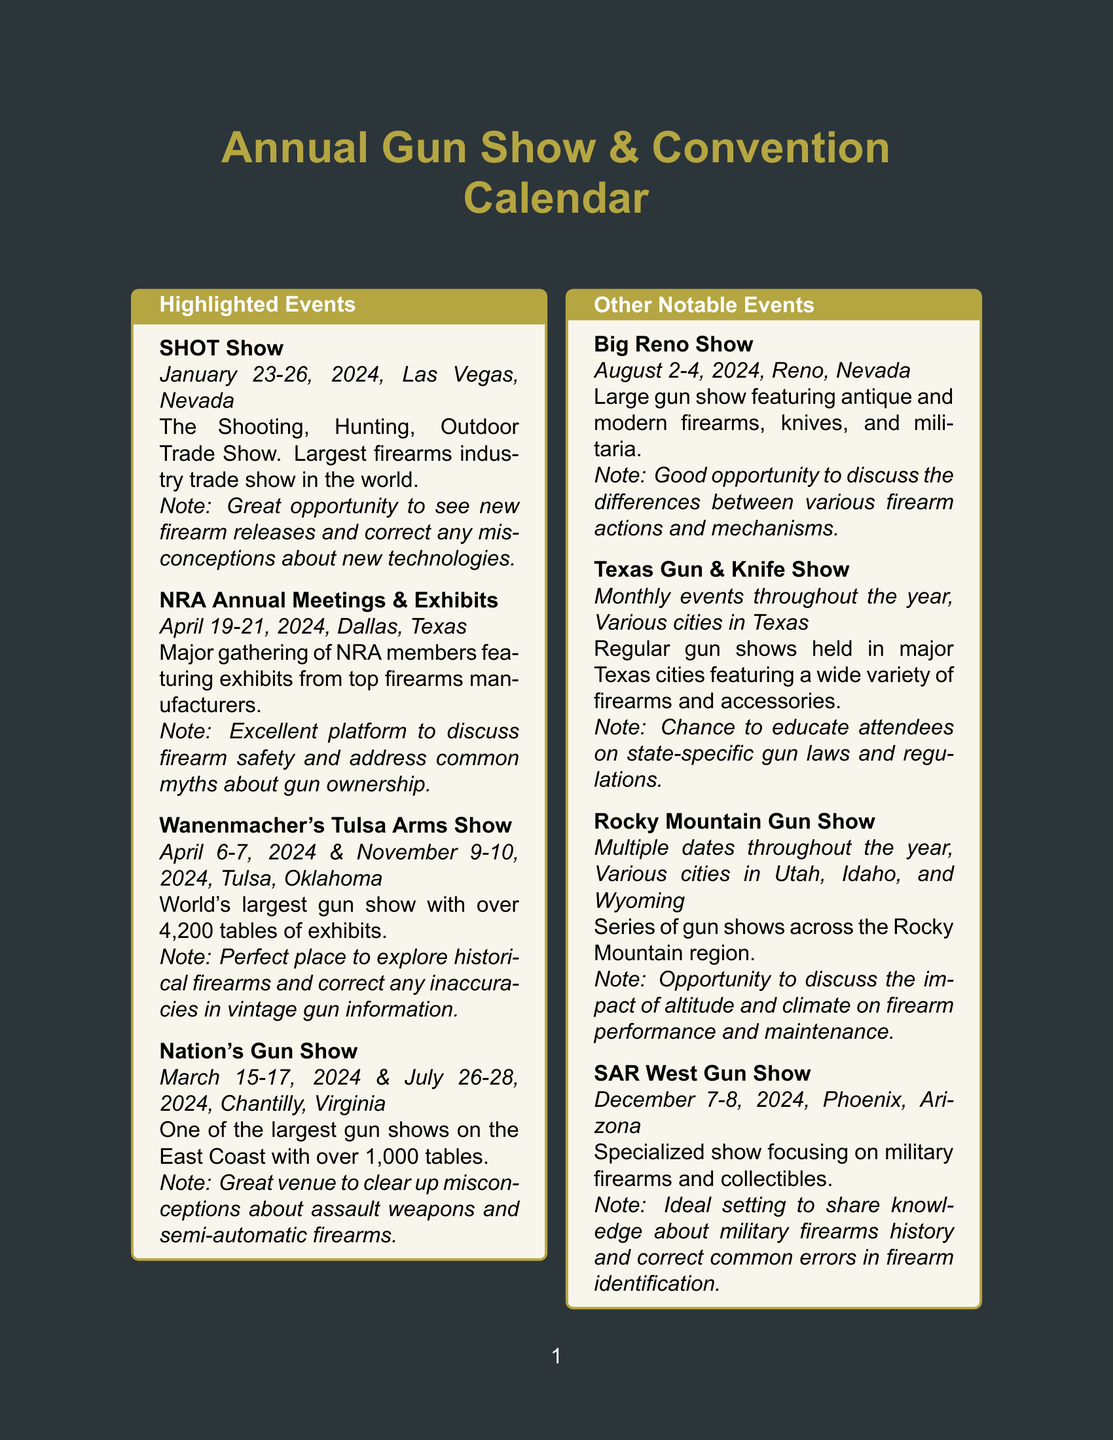What is the date of the SHOT Show? The date of the SHOT Show is specified in the document as January 23-26, 2024.
Answer: January 23-26, 2024 Where is the NRA Annual Meetings & Exhibits held? The location for the NRA Annual Meetings & Exhibits is mentioned as Dallas, Texas.
Answer: Dallas, Texas How many tables are at Wanenmacher's Tulsa Arms Show? The document states that Wanenmacher's Tulsa Arms Show has over 4,200 tables.
Answer: Over 4,200 tables What are the dates for the Nation's Gun Show? The document lists the dates for the Nation's Gun Show as March 15-17, 2024, and July 26-28, 2024.
Answer: March 15-17, 2024 & July 26-28, 2024 What is a key discussion point at the SHOT Show? The document notes that the SHOT Show is a great opportunity to see new firearm releases and correct misconceptions about new technologies.
Answer: Misconceptions about new technologies Which event occurs in December 2024? The document indicates that the SAR West Gun Show takes place in December 2024.
Answer: SAR West Gun Show Why is the Wanenmacher's Tulsa Arms Show highlighted? The document highlights it as the perfect place to explore historical firearms and correct inaccuracies in vintage gun information.
Answer: Explore historical firearms What type of firearms is the SAR West Gun Show focused on? The document specifies that the SAR West Gun Show specializes in military firearms and collectibles.
Answer: Military firearms What is the frequency of the Texas Gun & Knife Show? The document describes the Texas Gun & Knife Show as having monthly events throughout the year.
Answer: Monthly events throughout the year 